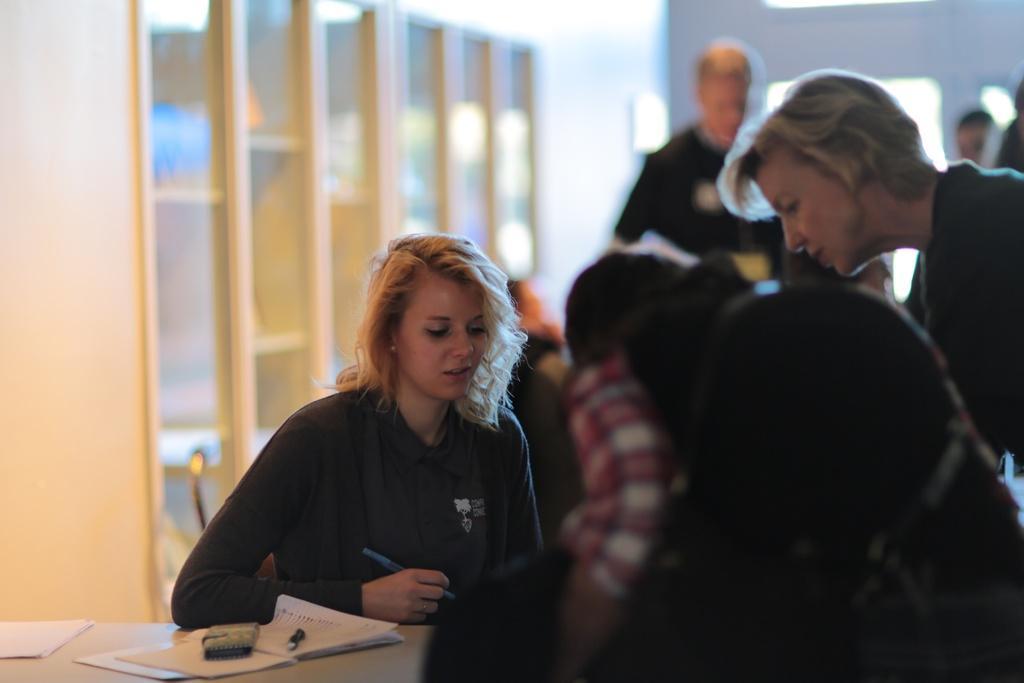In one or two sentences, can you explain what this image depicts? In this image we can see group of persons. In the center of the image we can see a woman holding a pen in her hand. In the bottom left corner of the image we can see some papers, device, a pen placed on the table. In the background, we can see cupboard and a wall. 